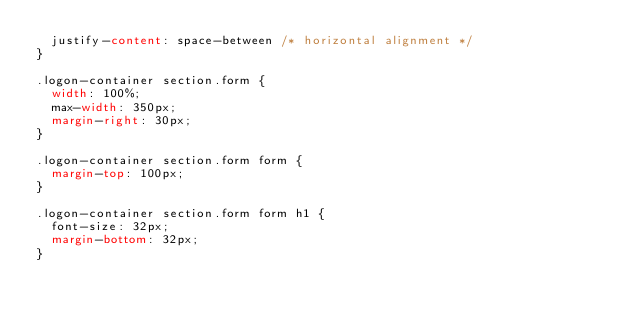<code> <loc_0><loc_0><loc_500><loc_500><_CSS_>  justify-content: space-between /* horizontal alignment */
}

.logon-container section.form {
  width: 100%;
  max-width: 350px;
  margin-right: 30px;
}

.logon-container section.form form {
  margin-top: 100px;
}

.logon-container section.form form h1 {
  font-size: 32px;
  margin-bottom: 32px;
}



 </code> 